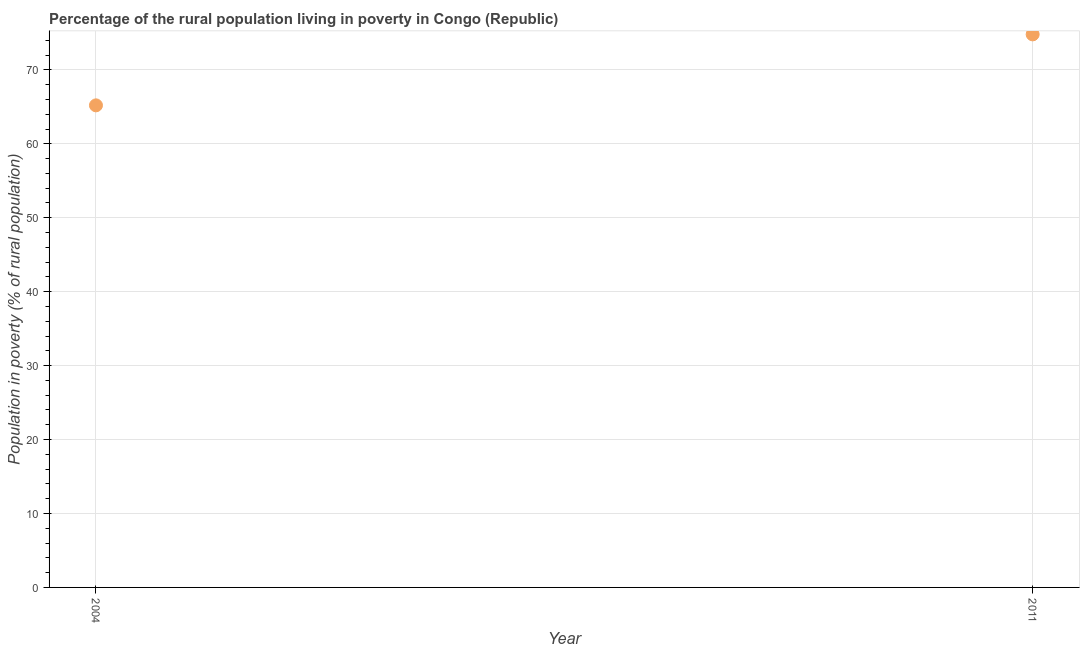What is the percentage of rural population living below poverty line in 2011?
Give a very brief answer. 74.8. Across all years, what is the maximum percentage of rural population living below poverty line?
Give a very brief answer. 74.8. Across all years, what is the minimum percentage of rural population living below poverty line?
Ensure brevity in your answer.  65.2. What is the sum of the percentage of rural population living below poverty line?
Your answer should be compact. 140. What is the difference between the percentage of rural population living below poverty line in 2004 and 2011?
Provide a short and direct response. -9.6. What is the average percentage of rural population living below poverty line per year?
Your response must be concise. 70. What is the median percentage of rural population living below poverty line?
Your response must be concise. 70. Do a majority of the years between 2011 and 2004 (inclusive) have percentage of rural population living below poverty line greater than 42 %?
Your response must be concise. No. What is the ratio of the percentage of rural population living below poverty line in 2004 to that in 2011?
Your answer should be very brief. 0.87. How many dotlines are there?
Ensure brevity in your answer.  1. How many years are there in the graph?
Offer a terse response. 2. What is the difference between two consecutive major ticks on the Y-axis?
Give a very brief answer. 10. Does the graph contain grids?
Offer a terse response. Yes. What is the title of the graph?
Give a very brief answer. Percentage of the rural population living in poverty in Congo (Republic). What is the label or title of the Y-axis?
Ensure brevity in your answer.  Population in poverty (% of rural population). What is the Population in poverty (% of rural population) in 2004?
Provide a short and direct response. 65.2. What is the Population in poverty (% of rural population) in 2011?
Make the answer very short. 74.8. What is the difference between the Population in poverty (% of rural population) in 2004 and 2011?
Your answer should be compact. -9.6. What is the ratio of the Population in poverty (% of rural population) in 2004 to that in 2011?
Offer a very short reply. 0.87. 